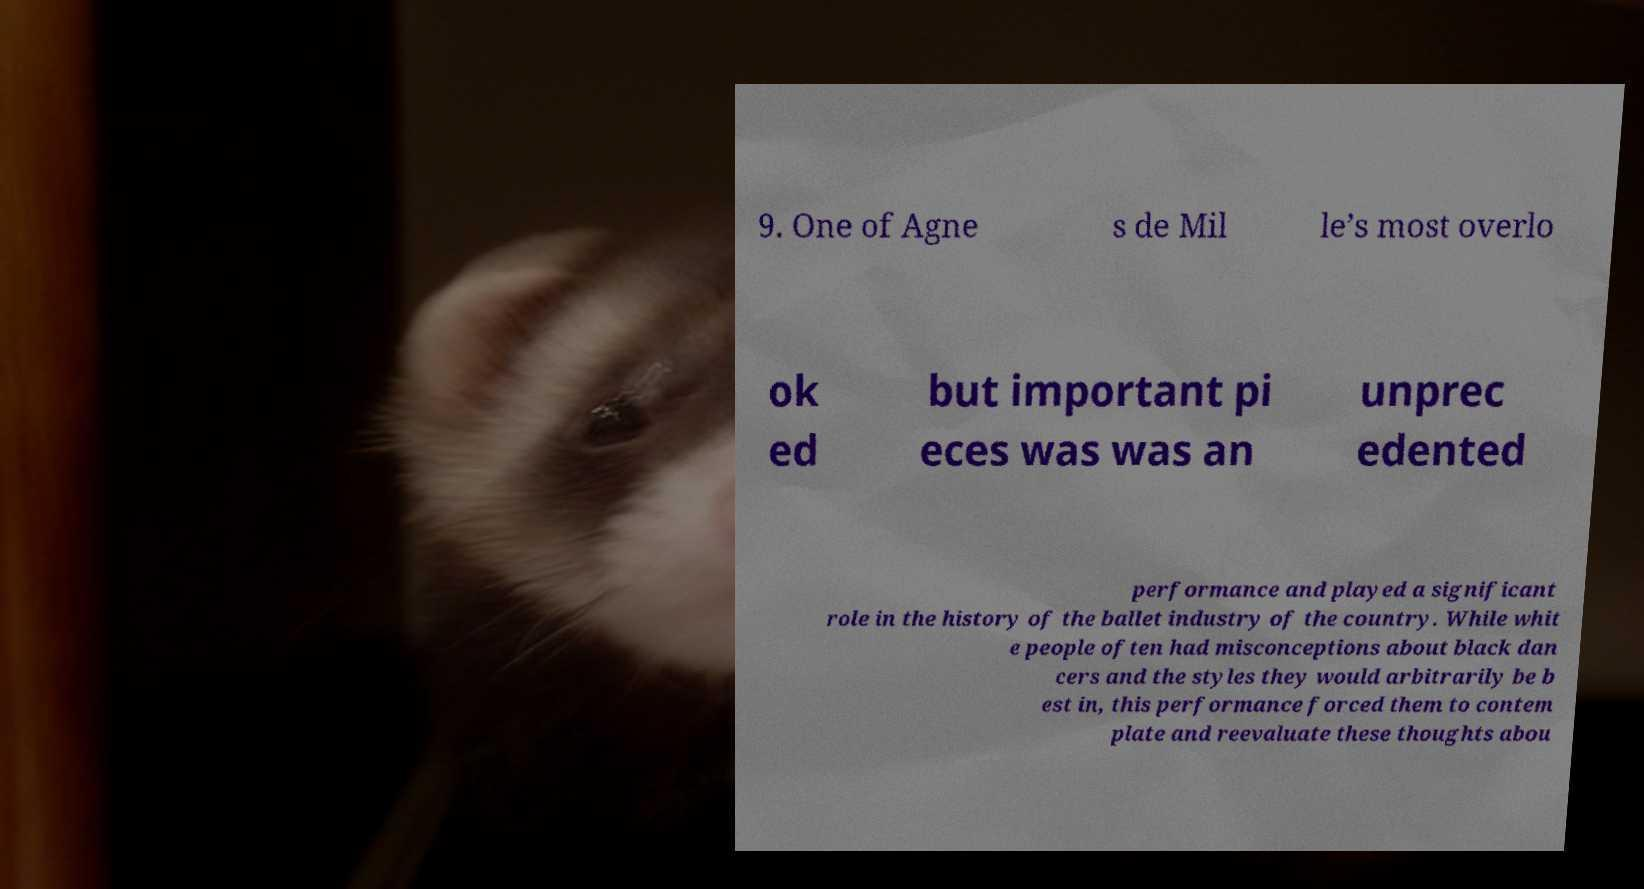There's text embedded in this image that I need extracted. Can you transcribe it verbatim? 9. One of Agne s de Mil le’s most overlo ok ed but important pi eces was was an unprec edented performance and played a significant role in the history of the ballet industry of the country. While whit e people often had misconceptions about black dan cers and the styles they would arbitrarily be b est in, this performance forced them to contem plate and reevaluate these thoughts abou 